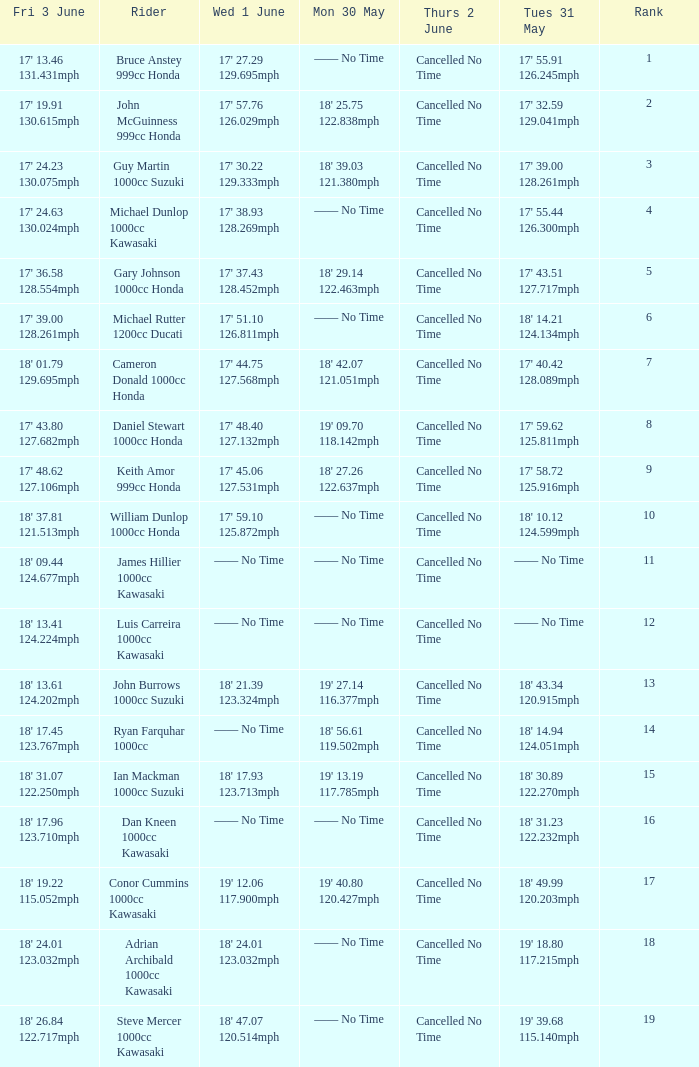What is the Fri 3 June time for the rider whose Tues 31 May time was 19' 18.80 117.215mph? 18' 24.01 123.032mph. 